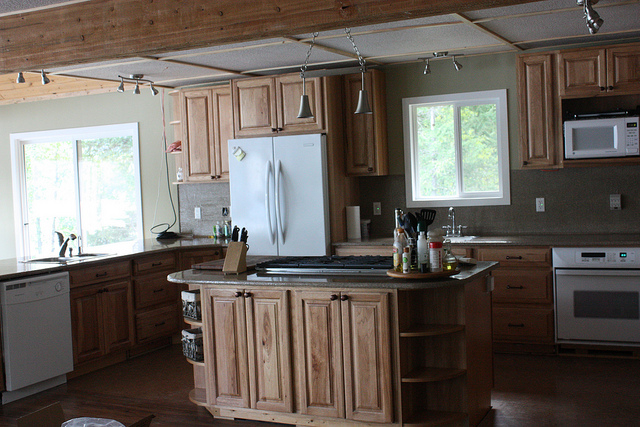<image>What is the orange thing? I don't know what the orange thing is. It can be various items such as a towel, ketchup, knick knack, lazy susan, lamp, lid, or food. What color is the range? I am not sure what color the range is. It could be white, gray, brown, or black. What color is the range? The range is white. What is the orange thing? I don't know what the orange thing is. It can be seen as a towel, ketchup, knick knack, lazy susan, lamp, lid, food, or bottle. 